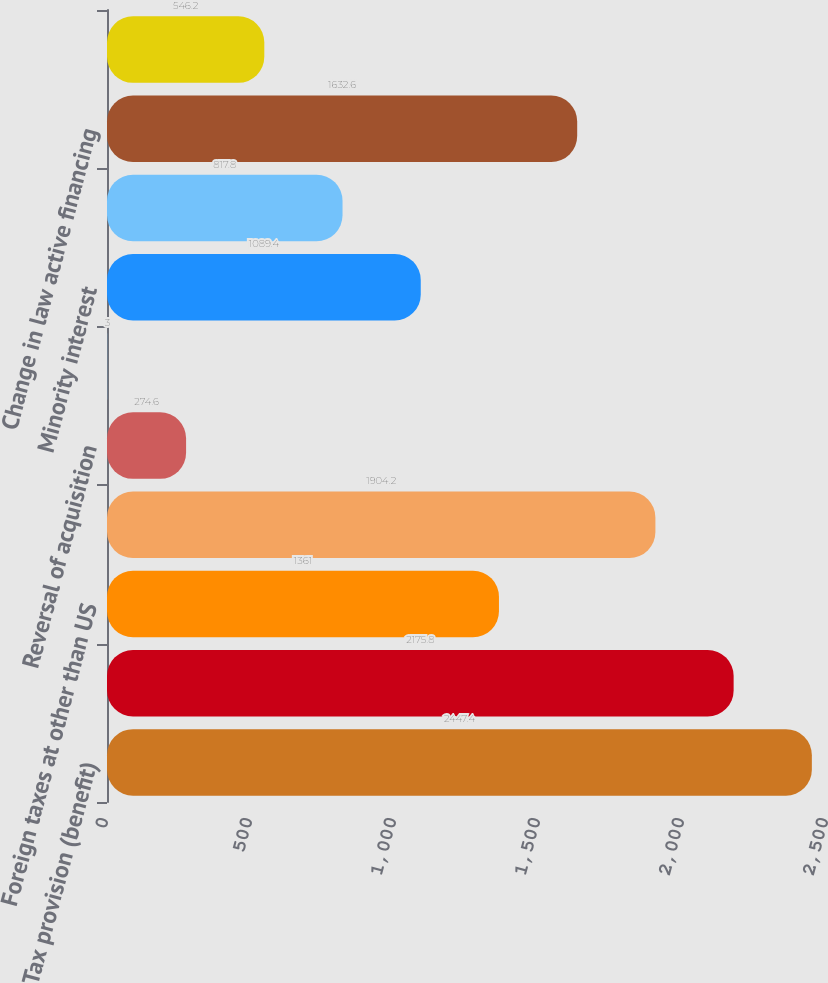Convert chart to OTSL. <chart><loc_0><loc_0><loc_500><loc_500><bar_chart><fcel>Tax provision (benefit)<fcel>Non-taxable investment income<fcel>Foreign taxes at other than US<fcel>Low income housing and other<fcel>Reversal of acquisition<fcel>Change in repatriation<fcel>Minority interest<fcel>Medicare Part D<fcel>Change in law active financing<fcel>Other<nl><fcel>2447.4<fcel>2175.8<fcel>1361<fcel>1904.2<fcel>274.6<fcel>3<fcel>1089.4<fcel>817.8<fcel>1632.6<fcel>546.2<nl></chart> 